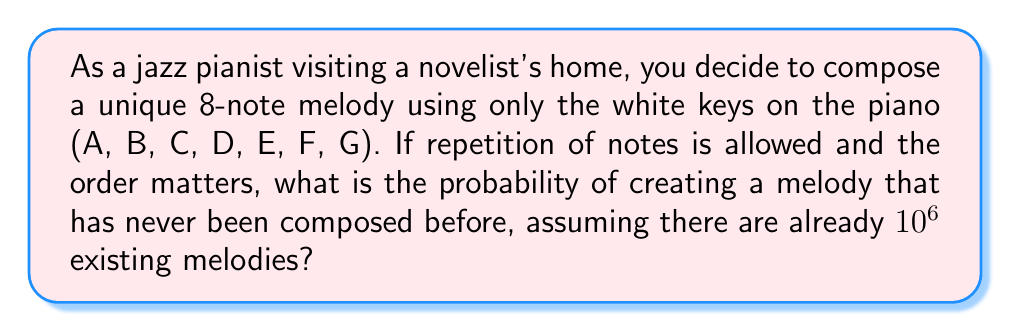Solve this math problem. Let's approach this step-by-step:

1) First, we need to calculate the total number of possible 8-note melodies:
   - There are 7 white keys to choose from for each note.
   - We can use any key multiple times, and the order matters.
   - This is a case of permutation with repetition.
   - The total number of possible melodies is: $7^8 = 5,764,801$

2) Now, we need to consider the existing melodies:
   - We're told there are $10^6 = 1,000,000$ existing melodies.

3) To find the probability of creating a unique melody, we need to calculate:
   $P(\text{unique}) = \frac{\text{number of unique melodies}}{\text{total possible melodies}}$

4) The number of unique melodies is:
   $5,764,801 - 1,000,000 = 4,764,801$

5) Therefore, the probability is:
   $P(\text{unique}) = \frac{4,764,801}{5,764,801} \approx 0.8265$

6) To express this as a percentage:
   $0.8265 \times 100\% \approx 82.65\%$
Answer: $82.65\%$ 